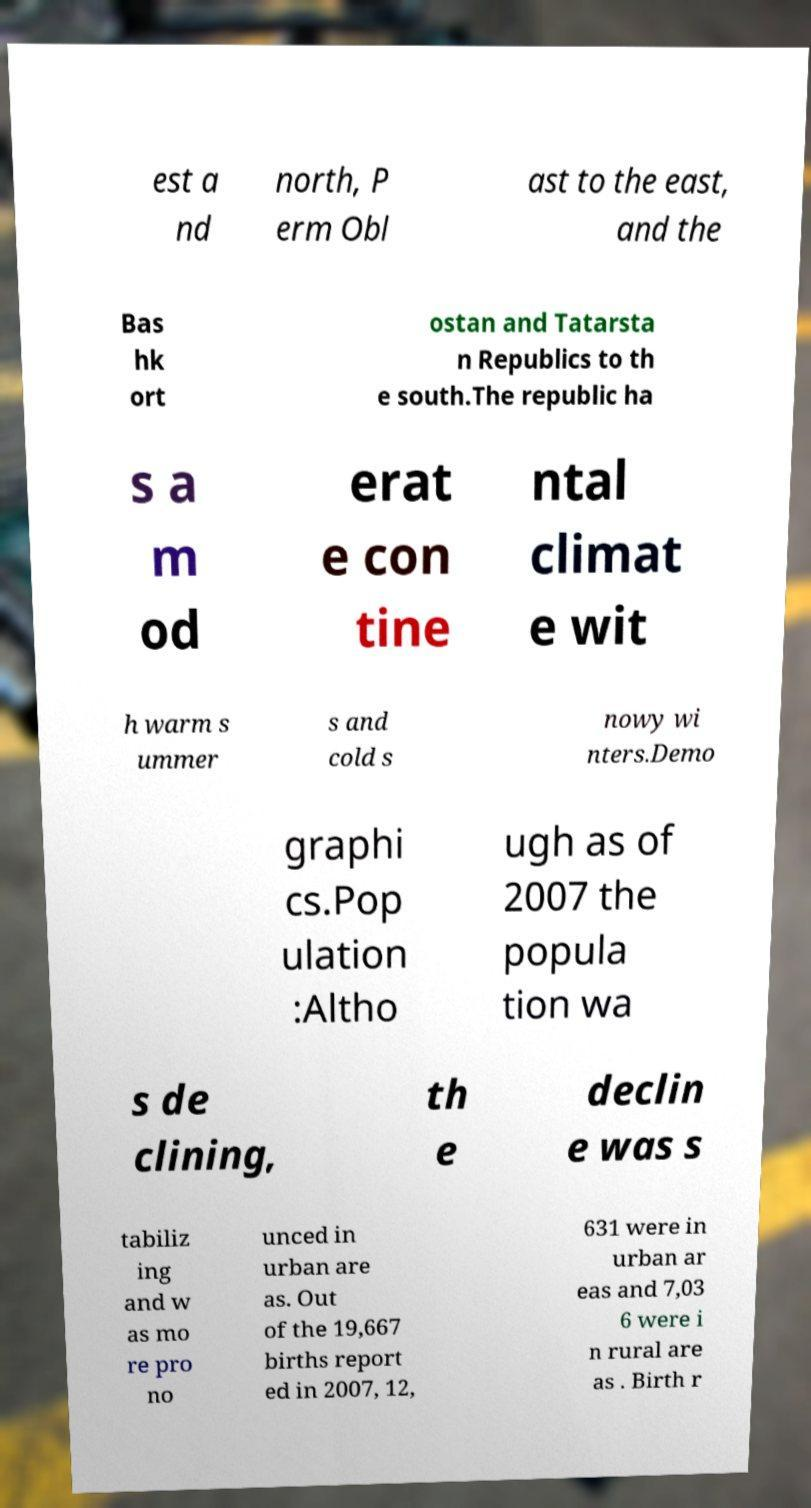What messages or text are displayed in this image? I need them in a readable, typed format. est a nd north, P erm Obl ast to the east, and the Bas hk ort ostan and Tatarsta n Republics to th e south.The republic ha s a m od erat e con tine ntal climat e wit h warm s ummer s and cold s nowy wi nters.Demo graphi cs.Pop ulation :Altho ugh as of 2007 the popula tion wa s de clining, th e declin e was s tabiliz ing and w as mo re pro no unced in urban are as. Out of the 19,667 births report ed in 2007, 12, 631 were in urban ar eas and 7,03 6 were i n rural are as . Birth r 